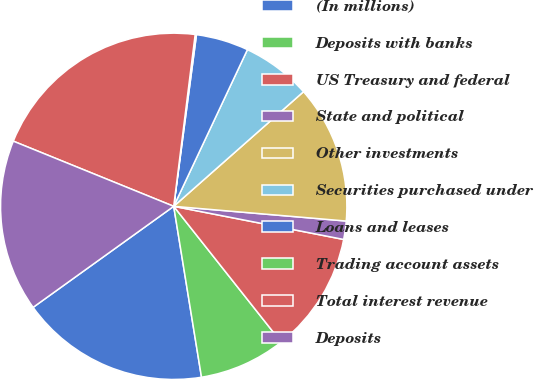Convert chart to OTSL. <chart><loc_0><loc_0><loc_500><loc_500><pie_chart><fcel>(In millions)<fcel>Deposits with banks<fcel>US Treasury and federal<fcel>State and political<fcel>Other investments<fcel>Securities purchased under<fcel>Loans and leases<fcel>Trading account assets<fcel>Total interest revenue<fcel>Deposits<nl><fcel>17.65%<fcel>8.09%<fcel>11.28%<fcel>1.71%<fcel>12.87%<fcel>6.49%<fcel>4.9%<fcel>0.12%<fcel>20.84%<fcel>16.06%<nl></chart> 